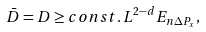Convert formula to latex. <formula><loc_0><loc_0><loc_500><loc_500>\bar { D } = D \geq c o n s t . \, L ^ { 2 - d } E _ { n \Delta P _ { x } } ,</formula> 